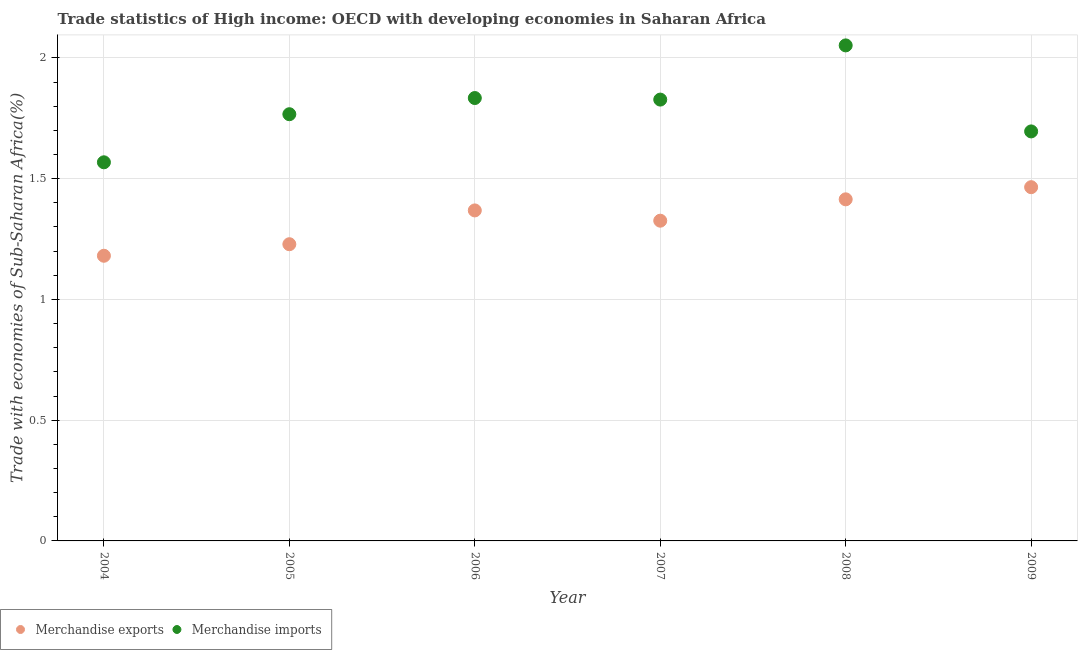Is the number of dotlines equal to the number of legend labels?
Provide a short and direct response. Yes. What is the merchandise imports in 2006?
Your answer should be compact. 1.83. Across all years, what is the maximum merchandise exports?
Provide a short and direct response. 1.46. Across all years, what is the minimum merchandise imports?
Your answer should be very brief. 1.57. What is the total merchandise exports in the graph?
Keep it short and to the point. 7.98. What is the difference between the merchandise exports in 2007 and that in 2009?
Your response must be concise. -0.14. What is the difference between the merchandise exports in 2006 and the merchandise imports in 2004?
Offer a terse response. -0.2. What is the average merchandise imports per year?
Offer a very short reply. 1.79. In the year 2004, what is the difference between the merchandise exports and merchandise imports?
Keep it short and to the point. -0.39. In how many years, is the merchandise imports greater than 1.3 %?
Give a very brief answer. 6. What is the ratio of the merchandise imports in 2005 to that in 2007?
Your answer should be compact. 0.97. Is the merchandise imports in 2004 less than that in 2009?
Your answer should be compact. Yes. Is the difference between the merchandise exports in 2006 and 2008 greater than the difference between the merchandise imports in 2006 and 2008?
Your answer should be compact. Yes. What is the difference between the highest and the second highest merchandise imports?
Make the answer very short. 0.22. What is the difference between the highest and the lowest merchandise imports?
Give a very brief answer. 0.48. Is the merchandise exports strictly less than the merchandise imports over the years?
Your response must be concise. Yes. How many dotlines are there?
Offer a very short reply. 2. What is the difference between two consecutive major ticks on the Y-axis?
Provide a short and direct response. 0.5. Are the values on the major ticks of Y-axis written in scientific E-notation?
Your answer should be very brief. No. Does the graph contain any zero values?
Make the answer very short. No. Does the graph contain grids?
Offer a very short reply. Yes. Where does the legend appear in the graph?
Keep it short and to the point. Bottom left. What is the title of the graph?
Give a very brief answer. Trade statistics of High income: OECD with developing economies in Saharan Africa. Does "Constant 2005 US$" appear as one of the legend labels in the graph?
Offer a terse response. No. What is the label or title of the Y-axis?
Give a very brief answer. Trade with economies of Sub-Saharan Africa(%). What is the Trade with economies of Sub-Saharan Africa(%) of Merchandise exports in 2004?
Your answer should be very brief. 1.18. What is the Trade with economies of Sub-Saharan Africa(%) of Merchandise imports in 2004?
Keep it short and to the point. 1.57. What is the Trade with economies of Sub-Saharan Africa(%) in Merchandise exports in 2005?
Your answer should be very brief. 1.23. What is the Trade with economies of Sub-Saharan Africa(%) of Merchandise imports in 2005?
Offer a very short reply. 1.77. What is the Trade with economies of Sub-Saharan Africa(%) of Merchandise exports in 2006?
Your answer should be compact. 1.37. What is the Trade with economies of Sub-Saharan Africa(%) in Merchandise imports in 2006?
Provide a succinct answer. 1.83. What is the Trade with economies of Sub-Saharan Africa(%) of Merchandise exports in 2007?
Make the answer very short. 1.33. What is the Trade with economies of Sub-Saharan Africa(%) of Merchandise imports in 2007?
Offer a very short reply. 1.83. What is the Trade with economies of Sub-Saharan Africa(%) of Merchandise exports in 2008?
Your answer should be very brief. 1.41. What is the Trade with economies of Sub-Saharan Africa(%) in Merchandise imports in 2008?
Ensure brevity in your answer.  2.05. What is the Trade with economies of Sub-Saharan Africa(%) of Merchandise exports in 2009?
Offer a terse response. 1.46. What is the Trade with economies of Sub-Saharan Africa(%) of Merchandise imports in 2009?
Your response must be concise. 1.7. Across all years, what is the maximum Trade with economies of Sub-Saharan Africa(%) of Merchandise exports?
Offer a very short reply. 1.46. Across all years, what is the maximum Trade with economies of Sub-Saharan Africa(%) of Merchandise imports?
Provide a succinct answer. 2.05. Across all years, what is the minimum Trade with economies of Sub-Saharan Africa(%) in Merchandise exports?
Make the answer very short. 1.18. Across all years, what is the minimum Trade with economies of Sub-Saharan Africa(%) of Merchandise imports?
Offer a terse response. 1.57. What is the total Trade with economies of Sub-Saharan Africa(%) of Merchandise exports in the graph?
Offer a very short reply. 7.98. What is the total Trade with economies of Sub-Saharan Africa(%) in Merchandise imports in the graph?
Keep it short and to the point. 10.74. What is the difference between the Trade with economies of Sub-Saharan Africa(%) in Merchandise exports in 2004 and that in 2005?
Your answer should be compact. -0.05. What is the difference between the Trade with economies of Sub-Saharan Africa(%) in Merchandise imports in 2004 and that in 2005?
Make the answer very short. -0.2. What is the difference between the Trade with economies of Sub-Saharan Africa(%) in Merchandise exports in 2004 and that in 2006?
Offer a terse response. -0.19. What is the difference between the Trade with economies of Sub-Saharan Africa(%) of Merchandise imports in 2004 and that in 2006?
Give a very brief answer. -0.27. What is the difference between the Trade with economies of Sub-Saharan Africa(%) of Merchandise exports in 2004 and that in 2007?
Offer a very short reply. -0.15. What is the difference between the Trade with economies of Sub-Saharan Africa(%) in Merchandise imports in 2004 and that in 2007?
Your answer should be very brief. -0.26. What is the difference between the Trade with economies of Sub-Saharan Africa(%) of Merchandise exports in 2004 and that in 2008?
Provide a succinct answer. -0.23. What is the difference between the Trade with economies of Sub-Saharan Africa(%) of Merchandise imports in 2004 and that in 2008?
Ensure brevity in your answer.  -0.48. What is the difference between the Trade with economies of Sub-Saharan Africa(%) in Merchandise exports in 2004 and that in 2009?
Your answer should be very brief. -0.28. What is the difference between the Trade with economies of Sub-Saharan Africa(%) in Merchandise imports in 2004 and that in 2009?
Offer a very short reply. -0.13. What is the difference between the Trade with economies of Sub-Saharan Africa(%) of Merchandise exports in 2005 and that in 2006?
Keep it short and to the point. -0.14. What is the difference between the Trade with economies of Sub-Saharan Africa(%) in Merchandise imports in 2005 and that in 2006?
Provide a short and direct response. -0.07. What is the difference between the Trade with economies of Sub-Saharan Africa(%) of Merchandise exports in 2005 and that in 2007?
Provide a short and direct response. -0.1. What is the difference between the Trade with economies of Sub-Saharan Africa(%) in Merchandise imports in 2005 and that in 2007?
Offer a very short reply. -0.06. What is the difference between the Trade with economies of Sub-Saharan Africa(%) of Merchandise exports in 2005 and that in 2008?
Offer a very short reply. -0.19. What is the difference between the Trade with economies of Sub-Saharan Africa(%) of Merchandise imports in 2005 and that in 2008?
Provide a succinct answer. -0.28. What is the difference between the Trade with economies of Sub-Saharan Africa(%) in Merchandise exports in 2005 and that in 2009?
Keep it short and to the point. -0.24. What is the difference between the Trade with economies of Sub-Saharan Africa(%) in Merchandise imports in 2005 and that in 2009?
Provide a short and direct response. 0.07. What is the difference between the Trade with economies of Sub-Saharan Africa(%) in Merchandise exports in 2006 and that in 2007?
Provide a succinct answer. 0.04. What is the difference between the Trade with economies of Sub-Saharan Africa(%) of Merchandise imports in 2006 and that in 2007?
Offer a very short reply. 0.01. What is the difference between the Trade with economies of Sub-Saharan Africa(%) of Merchandise exports in 2006 and that in 2008?
Provide a short and direct response. -0.05. What is the difference between the Trade with economies of Sub-Saharan Africa(%) in Merchandise imports in 2006 and that in 2008?
Ensure brevity in your answer.  -0.22. What is the difference between the Trade with economies of Sub-Saharan Africa(%) of Merchandise exports in 2006 and that in 2009?
Offer a terse response. -0.1. What is the difference between the Trade with economies of Sub-Saharan Africa(%) of Merchandise imports in 2006 and that in 2009?
Offer a terse response. 0.14. What is the difference between the Trade with economies of Sub-Saharan Africa(%) of Merchandise exports in 2007 and that in 2008?
Offer a very short reply. -0.09. What is the difference between the Trade with economies of Sub-Saharan Africa(%) in Merchandise imports in 2007 and that in 2008?
Your answer should be compact. -0.22. What is the difference between the Trade with economies of Sub-Saharan Africa(%) of Merchandise exports in 2007 and that in 2009?
Offer a terse response. -0.14. What is the difference between the Trade with economies of Sub-Saharan Africa(%) of Merchandise imports in 2007 and that in 2009?
Your answer should be compact. 0.13. What is the difference between the Trade with economies of Sub-Saharan Africa(%) of Merchandise exports in 2008 and that in 2009?
Make the answer very short. -0.05. What is the difference between the Trade with economies of Sub-Saharan Africa(%) in Merchandise imports in 2008 and that in 2009?
Give a very brief answer. 0.36. What is the difference between the Trade with economies of Sub-Saharan Africa(%) in Merchandise exports in 2004 and the Trade with economies of Sub-Saharan Africa(%) in Merchandise imports in 2005?
Offer a terse response. -0.59. What is the difference between the Trade with economies of Sub-Saharan Africa(%) in Merchandise exports in 2004 and the Trade with economies of Sub-Saharan Africa(%) in Merchandise imports in 2006?
Provide a succinct answer. -0.65. What is the difference between the Trade with economies of Sub-Saharan Africa(%) in Merchandise exports in 2004 and the Trade with economies of Sub-Saharan Africa(%) in Merchandise imports in 2007?
Ensure brevity in your answer.  -0.65. What is the difference between the Trade with economies of Sub-Saharan Africa(%) of Merchandise exports in 2004 and the Trade with economies of Sub-Saharan Africa(%) of Merchandise imports in 2008?
Give a very brief answer. -0.87. What is the difference between the Trade with economies of Sub-Saharan Africa(%) in Merchandise exports in 2004 and the Trade with economies of Sub-Saharan Africa(%) in Merchandise imports in 2009?
Provide a succinct answer. -0.51. What is the difference between the Trade with economies of Sub-Saharan Africa(%) of Merchandise exports in 2005 and the Trade with economies of Sub-Saharan Africa(%) of Merchandise imports in 2006?
Offer a terse response. -0.61. What is the difference between the Trade with economies of Sub-Saharan Africa(%) in Merchandise exports in 2005 and the Trade with economies of Sub-Saharan Africa(%) in Merchandise imports in 2007?
Your response must be concise. -0.6. What is the difference between the Trade with economies of Sub-Saharan Africa(%) of Merchandise exports in 2005 and the Trade with economies of Sub-Saharan Africa(%) of Merchandise imports in 2008?
Ensure brevity in your answer.  -0.82. What is the difference between the Trade with economies of Sub-Saharan Africa(%) of Merchandise exports in 2005 and the Trade with economies of Sub-Saharan Africa(%) of Merchandise imports in 2009?
Keep it short and to the point. -0.47. What is the difference between the Trade with economies of Sub-Saharan Africa(%) of Merchandise exports in 2006 and the Trade with economies of Sub-Saharan Africa(%) of Merchandise imports in 2007?
Your response must be concise. -0.46. What is the difference between the Trade with economies of Sub-Saharan Africa(%) of Merchandise exports in 2006 and the Trade with economies of Sub-Saharan Africa(%) of Merchandise imports in 2008?
Provide a succinct answer. -0.68. What is the difference between the Trade with economies of Sub-Saharan Africa(%) of Merchandise exports in 2006 and the Trade with economies of Sub-Saharan Africa(%) of Merchandise imports in 2009?
Keep it short and to the point. -0.33. What is the difference between the Trade with economies of Sub-Saharan Africa(%) in Merchandise exports in 2007 and the Trade with economies of Sub-Saharan Africa(%) in Merchandise imports in 2008?
Give a very brief answer. -0.73. What is the difference between the Trade with economies of Sub-Saharan Africa(%) of Merchandise exports in 2007 and the Trade with economies of Sub-Saharan Africa(%) of Merchandise imports in 2009?
Give a very brief answer. -0.37. What is the difference between the Trade with economies of Sub-Saharan Africa(%) in Merchandise exports in 2008 and the Trade with economies of Sub-Saharan Africa(%) in Merchandise imports in 2009?
Keep it short and to the point. -0.28. What is the average Trade with economies of Sub-Saharan Africa(%) of Merchandise exports per year?
Offer a very short reply. 1.33. What is the average Trade with economies of Sub-Saharan Africa(%) of Merchandise imports per year?
Your answer should be very brief. 1.79. In the year 2004, what is the difference between the Trade with economies of Sub-Saharan Africa(%) in Merchandise exports and Trade with economies of Sub-Saharan Africa(%) in Merchandise imports?
Make the answer very short. -0.39. In the year 2005, what is the difference between the Trade with economies of Sub-Saharan Africa(%) in Merchandise exports and Trade with economies of Sub-Saharan Africa(%) in Merchandise imports?
Provide a succinct answer. -0.54. In the year 2006, what is the difference between the Trade with economies of Sub-Saharan Africa(%) of Merchandise exports and Trade with economies of Sub-Saharan Africa(%) of Merchandise imports?
Your response must be concise. -0.47. In the year 2007, what is the difference between the Trade with economies of Sub-Saharan Africa(%) of Merchandise exports and Trade with economies of Sub-Saharan Africa(%) of Merchandise imports?
Provide a succinct answer. -0.5. In the year 2008, what is the difference between the Trade with economies of Sub-Saharan Africa(%) of Merchandise exports and Trade with economies of Sub-Saharan Africa(%) of Merchandise imports?
Make the answer very short. -0.64. In the year 2009, what is the difference between the Trade with economies of Sub-Saharan Africa(%) in Merchandise exports and Trade with economies of Sub-Saharan Africa(%) in Merchandise imports?
Your response must be concise. -0.23. What is the ratio of the Trade with economies of Sub-Saharan Africa(%) in Merchandise exports in 2004 to that in 2005?
Provide a succinct answer. 0.96. What is the ratio of the Trade with economies of Sub-Saharan Africa(%) of Merchandise imports in 2004 to that in 2005?
Your answer should be compact. 0.89. What is the ratio of the Trade with economies of Sub-Saharan Africa(%) in Merchandise exports in 2004 to that in 2006?
Ensure brevity in your answer.  0.86. What is the ratio of the Trade with economies of Sub-Saharan Africa(%) of Merchandise imports in 2004 to that in 2006?
Your response must be concise. 0.85. What is the ratio of the Trade with economies of Sub-Saharan Africa(%) of Merchandise exports in 2004 to that in 2007?
Give a very brief answer. 0.89. What is the ratio of the Trade with economies of Sub-Saharan Africa(%) in Merchandise imports in 2004 to that in 2007?
Offer a terse response. 0.86. What is the ratio of the Trade with economies of Sub-Saharan Africa(%) of Merchandise exports in 2004 to that in 2008?
Provide a succinct answer. 0.83. What is the ratio of the Trade with economies of Sub-Saharan Africa(%) in Merchandise imports in 2004 to that in 2008?
Your response must be concise. 0.76. What is the ratio of the Trade with economies of Sub-Saharan Africa(%) in Merchandise exports in 2004 to that in 2009?
Your answer should be compact. 0.81. What is the ratio of the Trade with economies of Sub-Saharan Africa(%) of Merchandise imports in 2004 to that in 2009?
Make the answer very short. 0.92. What is the ratio of the Trade with economies of Sub-Saharan Africa(%) of Merchandise exports in 2005 to that in 2006?
Provide a succinct answer. 0.9. What is the ratio of the Trade with economies of Sub-Saharan Africa(%) in Merchandise imports in 2005 to that in 2006?
Your answer should be compact. 0.96. What is the ratio of the Trade with economies of Sub-Saharan Africa(%) of Merchandise exports in 2005 to that in 2007?
Give a very brief answer. 0.93. What is the ratio of the Trade with economies of Sub-Saharan Africa(%) in Merchandise imports in 2005 to that in 2007?
Offer a terse response. 0.97. What is the ratio of the Trade with economies of Sub-Saharan Africa(%) in Merchandise exports in 2005 to that in 2008?
Give a very brief answer. 0.87. What is the ratio of the Trade with economies of Sub-Saharan Africa(%) of Merchandise imports in 2005 to that in 2008?
Give a very brief answer. 0.86. What is the ratio of the Trade with economies of Sub-Saharan Africa(%) of Merchandise exports in 2005 to that in 2009?
Keep it short and to the point. 0.84. What is the ratio of the Trade with economies of Sub-Saharan Africa(%) in Merchandise imports in 2005 to that in 2009?
Your answer should be compact. 1.04. What is the ratio of the Trade with economies of Sub-Saharan Africa(%) of Merchandise exports in 2006 to that in 2007?
Keep it short and to the point. 1.03. What is the ratio of the Trade with economies of Sub-Saharan Africa(%) of Merchandise exports in 2006 to that in 2008?
Offer a terse response. 0.97. What is the ratio of the Trade with economies of Sub-Saharan Africa(%) in Merchandise imports in 2006 to that in 2008?
Offer a very short reply. 0.89. What is the ratio of the Trade with economies of Sub-Saharan Africa(%) of Merchandise exports in 2006 to that in 2009?
Make the answer very short. 0.93. What is the ratio of the Trade with economies of Sub-Saharan Africa(%) of Merchandise imports in 2006 to that in 2009?
Provide a short and direct response. 1.08. What is the ratio of the Trade with economies of Sub-Saharan Africa(%) in Merchandise imports in 2007 to that in 2008?
Provide a short and direct response. 0.89. What is the ratio of the Trade with economies of Sub-Saharan Africa(%) of Merchandise exports in 2007 to that in 2009?
Keep it short and to the point. 0.91. What is the ratio of the Trade with economies of Sub-Saharan Africa(%) in Merchandise imports in 2007 to that in 2009?
Give a very brief answer. 1.08. What is the ratio of the Trade with economies of Sub-Saharan Africa(%) in Merchandise exports in 2008 to that in 2009?
Offer a very short reply. 0.97. What is the ratio of the Trade with economies of Sub-Saharan Africa(%) of Merchandise imports in 2008 to that in 2009?
Offer a very short reply. 1.21. What is the difference between the highest and the second highest Trade with economies of Sub-Saharan Africa(%) of Merchandise exports?
Give a very brief answer. 0.05. What is the difference between the highest and the second highest Trade with economies of Sub-Saharan Africa(%) of Merchandise imports?
Offer a very short reply. 0.22. What is the difference between the highest and the lowest Trade with economies of Sub-Saharan Africa(%) in Merchandise exports?
Provide a succinct answer. 0.28. What is the difference between the highest and the lowest Trade with economies of Sub-Saharan Africa(%) in Merchandise imports?
Your answer should be compact. 0.48. 